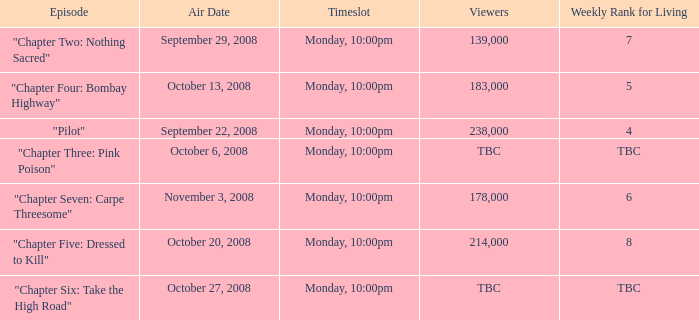What is the episode with the 183,000 viewers? "Chapter Four: Bombay Highway". 